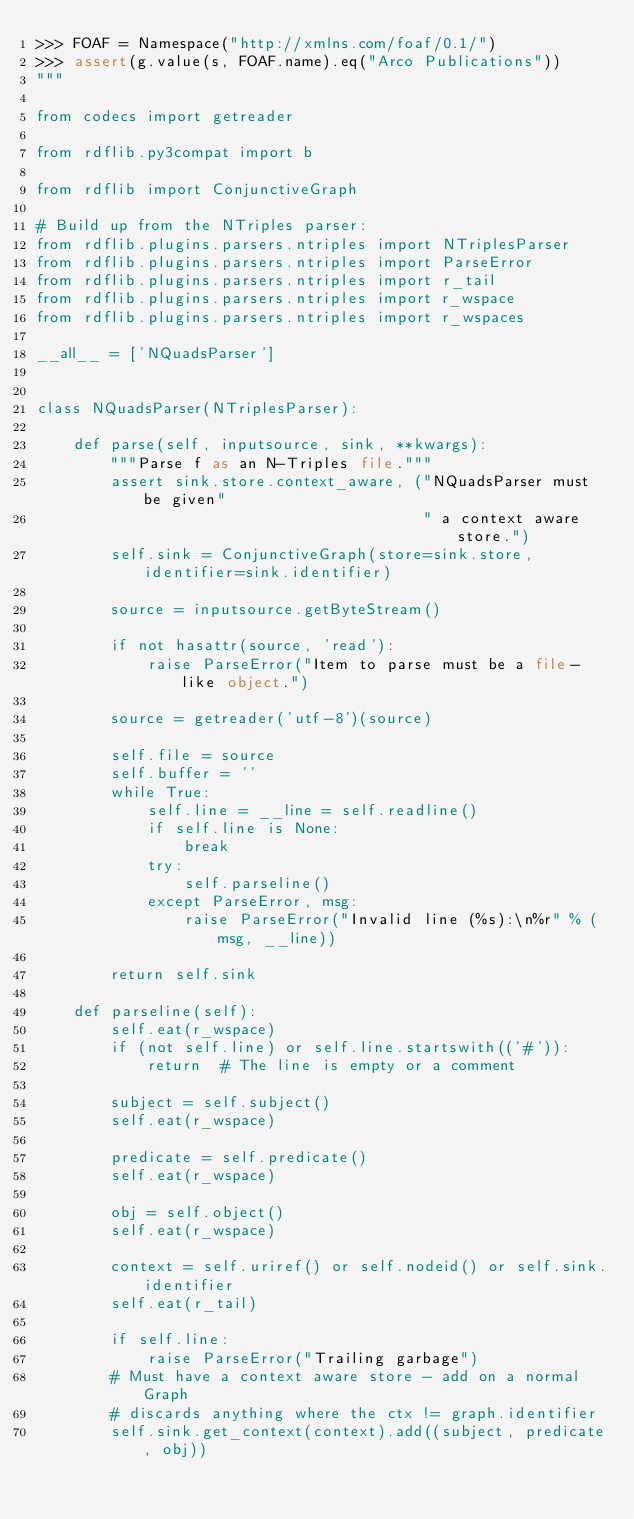Convert code to text. <code><loc_0><loc_0><loc_500><loc_500><_Python_>>>> FOAF = Namespace("http://xmlns.com/foaf/0.1/")
>>> assert(g.value(s, FOAF.name).eq("Arco Publications"))
"""

from codecs import getreader

from rdflib.py3compat import b

from rdflib import ConjunctiveGraph

# Build up from the NTriples parser:
from rdflib.plugins.parsers.ntriples import NTriplesParser
from rdflib.plugins.parsers.ntriples import ParseError
from rdflib.plugins.parsers.ntriples import r_tail
from rdflib.plugins.parsers.ntriples import r_wspace
from rdflib.plugins.parsers.ntriples import r_wspaces

__all__ = ['NQuadsParser']


class NQuadsParser(NTriplesParser):

    def parse(self, inputsource, sink, **kwargs):
        """Parse f as an N-Triples file."""
        assert sink.store.context_aware, ("NQuadsParser must be given"
                                          " a context aware store.")
        self.sink = ConjunctiveGraph(store=sink.store, identifier=sink.identifier)

        source = inputsource.getByteStream()

        if not hasattr(source, 'read'):
            raise ParseError("Item to parse must be a file-like object.")

        source = getreader('utf-8')(source)

        self.file = source
        self.buffer = ''
        while True:
            self.line = __line = self.readline()
            if self.line is None:
                break
            try:
                self.parseline()
            except ParseError, msg:
                raise ParseError("Invalid line (%s):\n%r" % (msg, __line))

        return self.sink

    def parseline(self):
        self.eat(r_wspace)
        if (not self.line) or self.line.startswith(('#')):
            return  # The line is empty or a comment

        subject = self.subject()
        self.eat(r_wspace)

        predicate = self.predicate()
        self.eat(r_wspace)

        obj = self.object()
        self.eat(r_wspace)

        context = self.uriref() or self.nodeid() or self.sink.identifier
        self.eat(r_tail)

        if self.line:
            raise ParseError("Trailing garbage")
        # Must have a context aware store - add on a normal Graph
        # discards anything where the ctx != graph.identifier
        self.sink.get_context(context).add((subject, predicate, obj))
</code> 